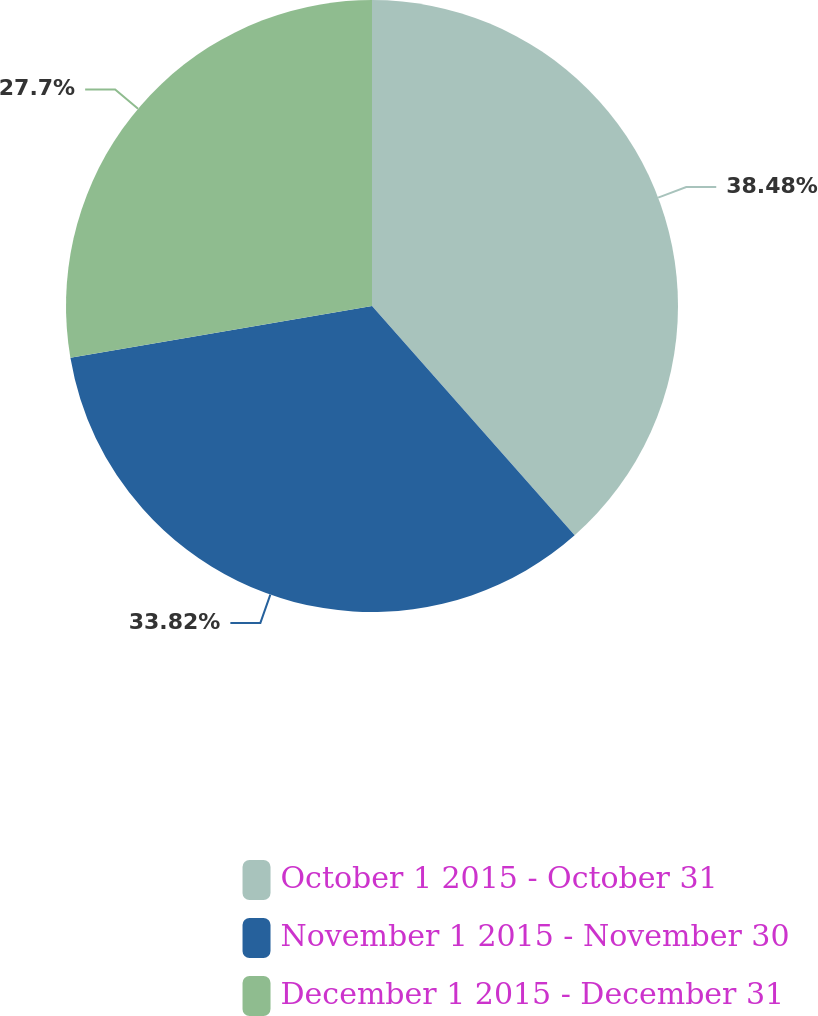Convert chart to OTSL. <chart><loc_0><loc_0><loc_500><loc_500><pie_chart><fcel>October 1 2015 - October 31<fcel>November 1 2015 - November 30<fcel>December 1 2015 - December 31<nl><fcel>38.48%<fcel>33.82%<fcel>27.7%<nl></chart> 